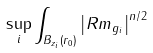<formula> <loc_0><loc_0><loc_500><loc_500>\sup _ { i } \int _ { B _ { z _ { i } } \left ( r _ { 0 } \right ) } \left | R m _ { g _ { i } } \right | ^ { n / 2 }</formula> 